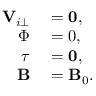Convert formula to latex. <formula><loc_0><loc_0><loc_500><loc_500>\begin{array} { r l } { { \mathbf V } _ { i \perp } } & = 0 , } \\ { \Phi } & = { 0 } , } \\ { \tau } & = 0 , } \\ { \mathbf B } & = \mathbf B _ { 0 } . } \end{array}</formula> 